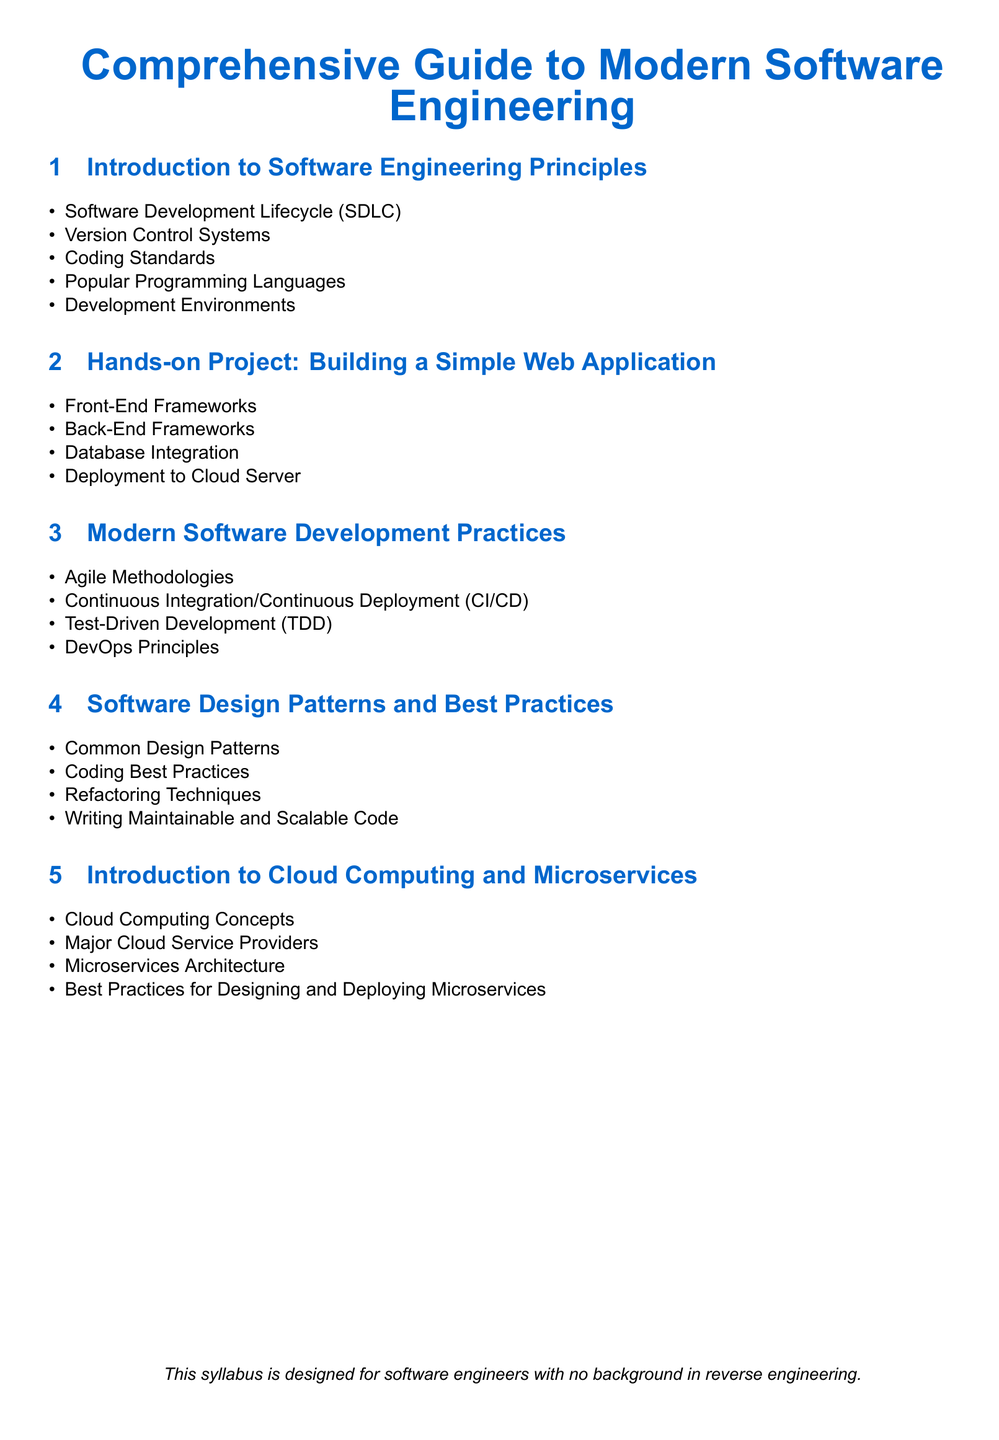What is covered in the first section? The first section includes fundamental concepts such as software development lifecycle, version control, and coding standards.
Answer: Software Development Lifecycle, Version Control Systems, Coding Standards, Popular Programming Languages, Development Environments What is a topic included in the hands-on project? This asks for a specific topic mentioned in the hands-on project section, which includes practical aspects of web application development.
Answer: Front-End Frameworks What development methodology is discussed in the modern practices section? This question seeks to identify one of the methodologies covered in the modern software development practices section.
Answer: Agile Methodologies Which architectural approach is introduced in the fifth section? The question pertains to the architectural approach discussed in the cloud computing section of the syllabus.
Answer: Microservices Architecture How many major cloud service providers are mentioned? This asks for a specific numeric detail related to the cloud computing concepts in this section.
Answer: Three What is emphasized as important for writing code? The directive seeks to identify key practices highlighted in the software design patterns and best practices section.
Answer: Writing Maintainable and Scalable Code What programming practice is linked with ensuring code quality? This question connects a specific practice discussed under modern software development practices related to maintaining code quality.
Answer: Test-Driven Development What is the result of deploying an application to the cloud server? The question prompts for the outcome of a specific task within the hands-on project.
Answer: Deployment to Cloud Server 